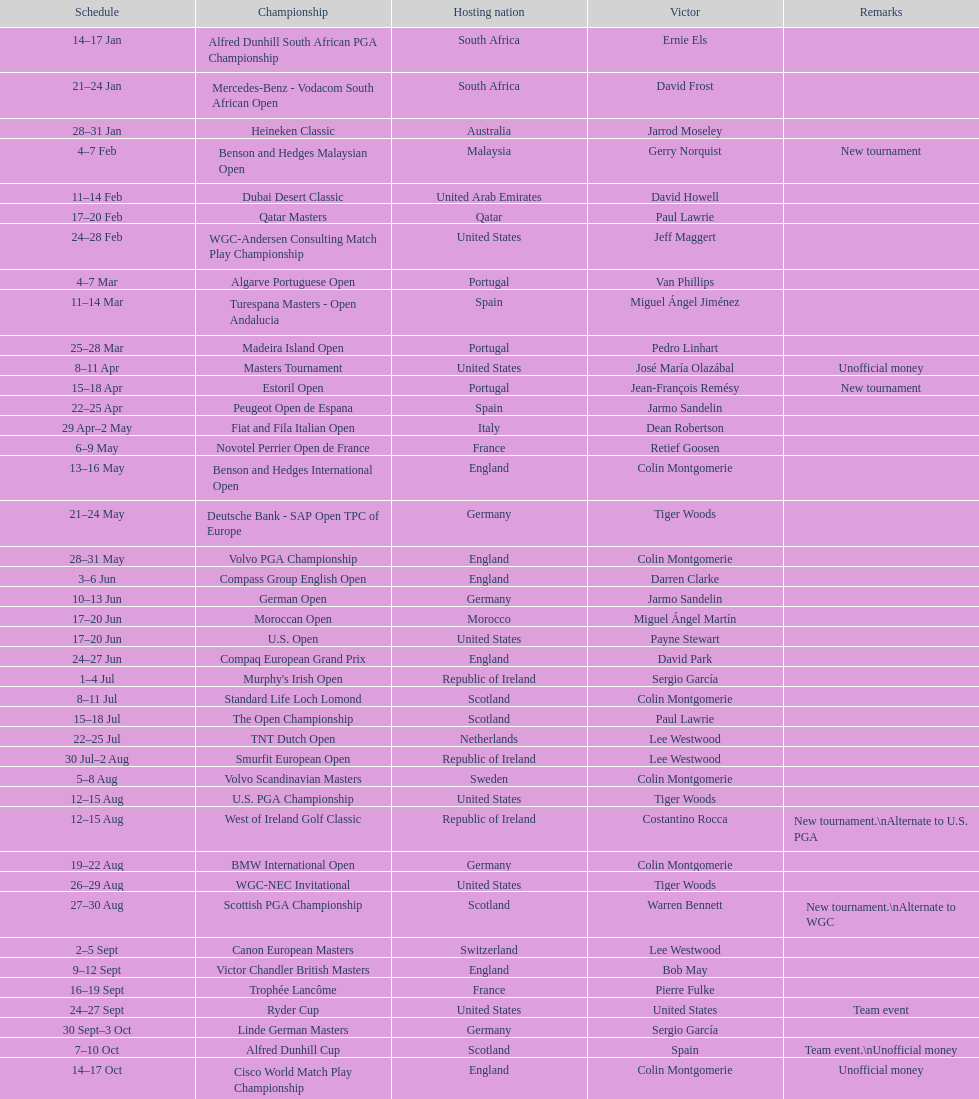How many consecutive times was south africa the host country? 2. 